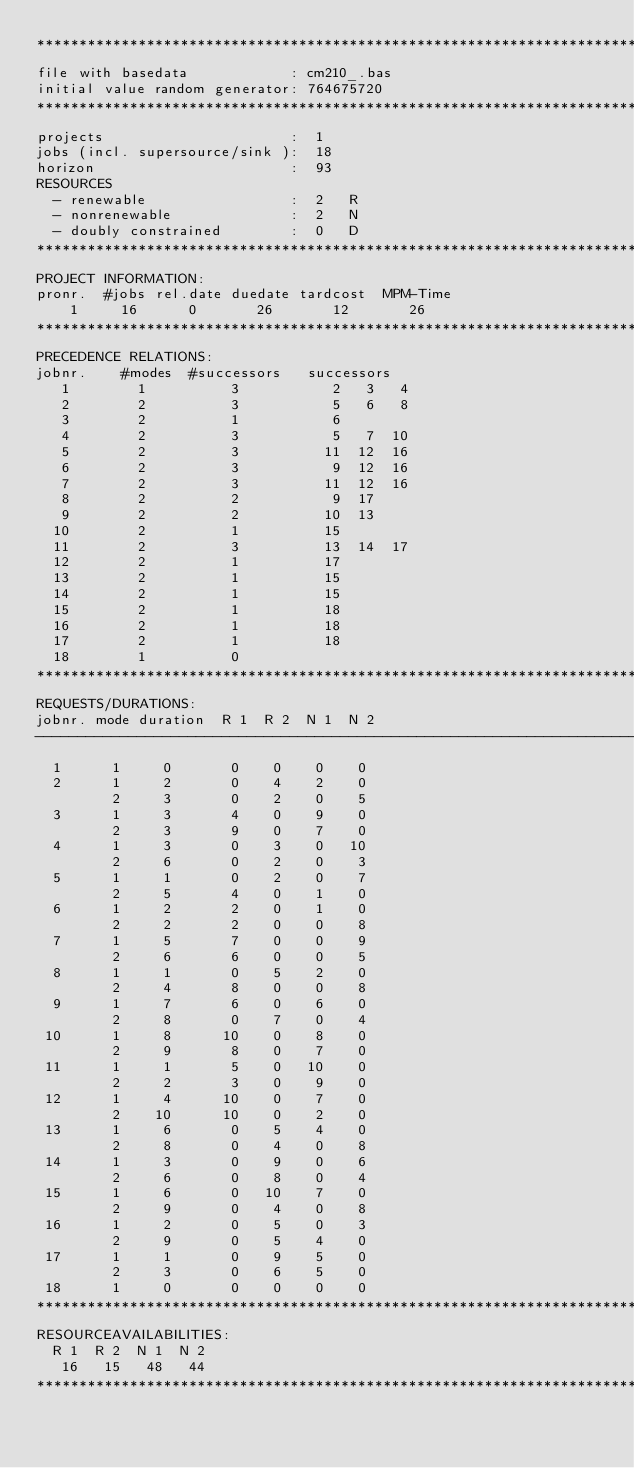<code> <loc_0><loc_0><loc_500><loc_500><_ObjectiveC_>************************************************************************
file with basedata            : cm210_.bas
initial value random generator: 764675720
************************************************************************
projects                      :  1
jobs (incl. supersource/sink ):  18
horizon                       :  93
RESOURCES
  - renewable                 :  2   R
  - nonrenewable              :  2   N
  - doubly constrained        :  0   D
************************************************************************
PROJECT INFORMATION:
pronr.  #jobs rel.date duedate tardcost  MPM-Time
    1     16      0       26       12       26
************************************************************************
PRECEDENCE RELATIONS:
jobnr.    #modes  #successors   successors
   1        1          3           2   3   4
   2        2          3           5   6   8
   3        2          1           6
   4        2          3           5   7  10
   5        2          3          11  12  16
   6        2          3           9  12  16
   7        2          3          11  12  16
   8        2          2           9  17
   9        2          2          10  13
  10        2          1          15
  11        2          3          13  14  17
  12        2          1          17
  13        2          1          15
  14        2          1          15
  15        2          1          18
  16        2          1          18
  17        2          1          18
  18        1          0        
************************************************************************
REQUESTS/DURATIONS:
jobnr. mode duration  R 1  R 2  N 1  N 2
------------------------------------------------------------------------
  1      1     0       0    0    0    0
  2      1     2       0    4    2    0
         2     3       0    2    0    5
  3      1     3       4    0    9    0
         2     3       9    0    7    0
  4      1     3       0    3    0   10
         2     6       0    2    0    3
  5      1     1       0    2    0    7
         2     5       4    0    1    0
  6      1     2       2    0    1    0
         2     2       2    0    0    8
  7      1     5       7    0    0    9
         2     6       6    0    0    5
  8      1     1       0    5    2    0
         2     4       8    0    0    8
  9      1     7       6    0    6    0
         2     8       0    7    0    4
 10      1     8      10    0    8    0
         2     9       8    0    7    0
 11      1     1       5    0   10    0
         2     2       3    0    9    0
 12      1     4      10    0    7    0
         2    10      10    0    2    0
 13      1     6       0    5    4    0
         2     8       0    4    0    8
 14      1     3       0    9    0    6
         2     6       0    8    0    4
 15      1     6       0   10    7    0
         2     9       0    4    0    8
 16      1     2       0    5    0    3
         2     9       0    5    4    0
 17      1     1       0    9    5    0
         2     3       0    6    5    0
 18      1     0       0    0    0    0
************************************************************************
RESOURCEAVAILABILITIES:
  R 1  R 2  N 1  N 2
   16   15   48   44
************************************************************************
</code> 